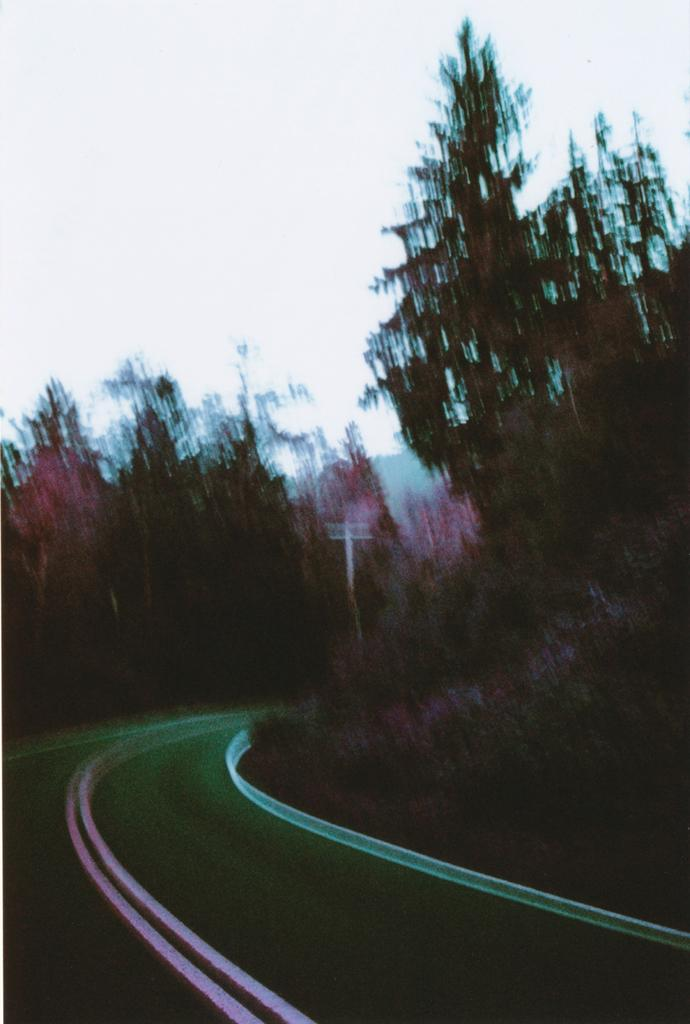What type of vegetation can be seen in the image? There are trees in the image. What can be seen running through the image? There is a road in the image. What is visible above the trees and road in the image? The sky is visible in the image. How many eggs are on the fan in the image? There are no eggs or fans present in the image. 